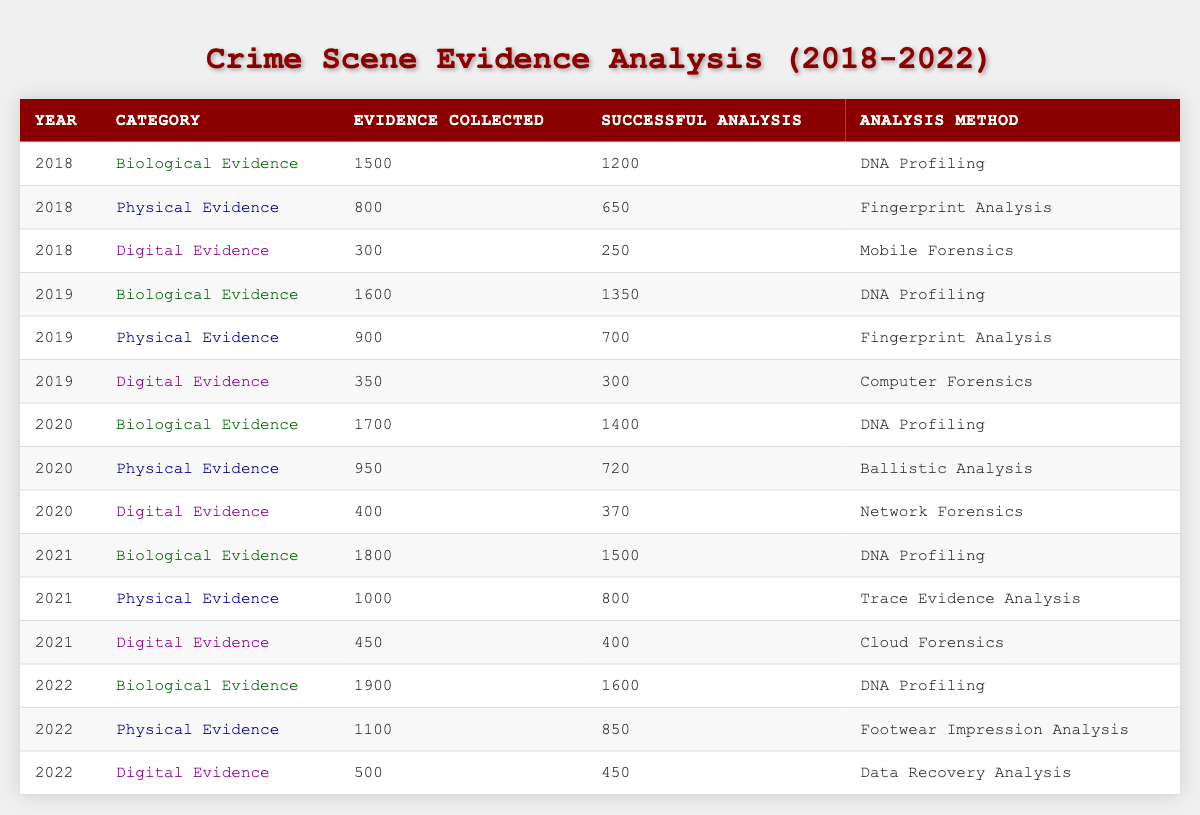What was the total number of Biological Evidence collected in 2021? In 2021, the table shows that 1800 biological evidence samples were collected.
Answer: 1800 How many successful analyses were conducted on Physical Evidence in 2022? The table indicates that 850 successful analyses were conducted on Physical Evidence in 2022.
Answer: 850 What was the year with the highest number of Digital Evidence collected? According to the table, 2022 had the most Digital Evidence collected with 500 samples.
Answer: 2022 How many more Biological Evidence samples were collected in 2020 than in 2018? In 2018, 1500 Biological Evidence samples were collected and in 2020, 1700 were collected. The difference is 1700 - 1500 = 200.
Answer: 200 Was the number of Successful Analyses greater than the number of Evidence Collected for Digital Evidence in 2019? The table shows that 300 Digital Evidence samples were successful analyzed while 350 were collected, so yes, the number of successful analyses was less than collected.
Answer: No What is the average number of successful analysis for Physical Evidence across all years? For Physical Evidence: 650 (2018) + 700 (2019) + 720 (2020) + 800 (2021) + 850 (2022) = 4020. There are 5 years, so average is 4020 / 5 = 804.
Answer: 804 In which year did the percentage of successful analysis reach over 80% for Biological Evidence? The successful analyses for Biological Evidence were 1200 (2018), 1350 (2019), 1400 (2020), 1500 (2021), and 1600 (2022). The percentage calculations are as follows: (1200/1500) * 100 = 80%, (1350/1600) * 100 = 84.37%, (1400/1700) * 100 = 82.35%, (1500/1800) * 100 = 83.33%, (1600/1900) * 100 = 84.21%. Thus, 2019 was the first year above 80%.
Answer: 2019 What is the difference in the total number of Successful Analyses conducted for all categories between 2021 and 2022? In 2021, the total successful analyses are 1500 (Biological) + 800 (Physical) + 400 (Digital) = 2700. For 2022, the totals are 1600 (Biological) + 850 (Physical) + 450 (Digital) = 2900. The difference is 2900 - 2700 = 200.
Answer: 200 Is the number of DNA Profiling analyses consistently increasing each year from 2018 to 2022? The successful analyses for DNA Profiling are 1200 (2018), 1350 (2019), 1400 (2020), 1500 (2021), and 1600 (2022), showing a consistent increase each year.
Answer: Yes What was the highest number of Evidence Collected from any category in a single year? From the table, the highest number of Evidence Collected is 1900 for Biological Evidence in 2022.
Answer: 1900 